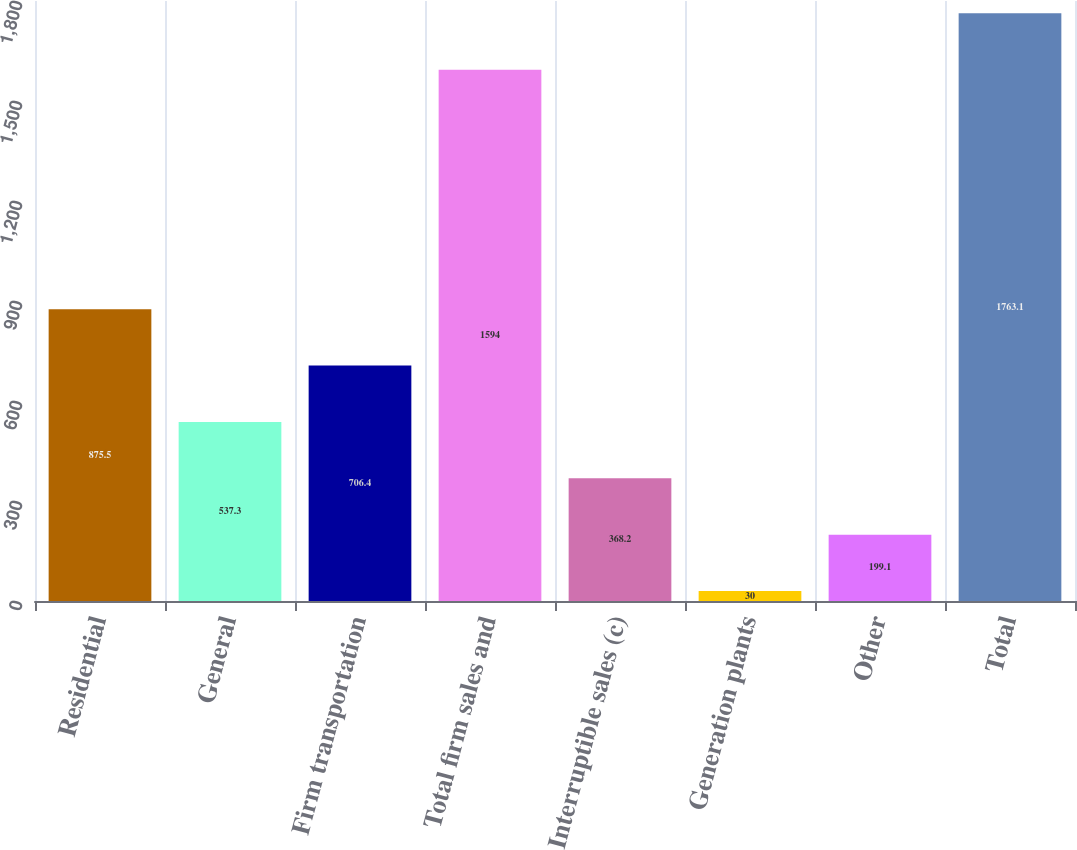<chart> <loc_0><loc_0><loc_500><loc_500><bar_chart><fcel>Residential<fcel>General<fcel>Firm transportation<fcel>Total firm sales and<fcel>Interruptible sales (c)<fcel>Generation plants<fcel>Other<fcel>Total<nl><fcel>875.5<fcel>537.3<fcel>706.4<fcel>1594<fcel>368.2<fcel>30<fcel>199.1<fcel>1763.1<nl></chart> 